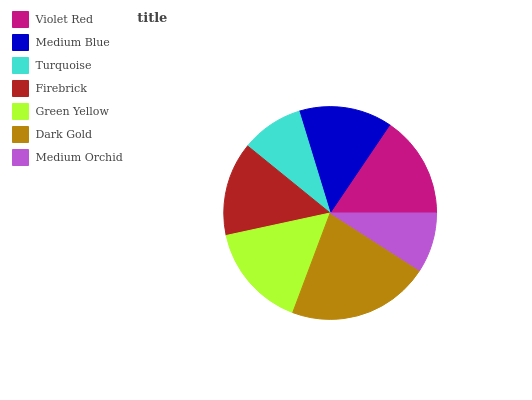Is Medium Orchid the minimum?
Answer yes or no. Yes. Is Dark Gold the maximum?
Answer yes or no. Yes. Is Medium Blue the minimum?
Answer yes or no. No. Is Medium Blue the maximum?
Answer yes or no. No. Is Violet Red greater than Medium Blue?
Answer yes or no. Yes. Is Medium Blue less than Violet Red?
Answer yes or no. Yes. Is Medium Blue greater than Violet Red?
Answer yes or no. No. Is Violet Red less than Medium Blue?
Answer yes or no. No. Is Firebrick the high median?
Answer yes or no. Yes. Is Firebrick the low median?
Answer yes or no. Yes. Is Dark Gold the high median?
Answer yes or no. No. Is Violet Red the low median?
Answer yes or no. No. 